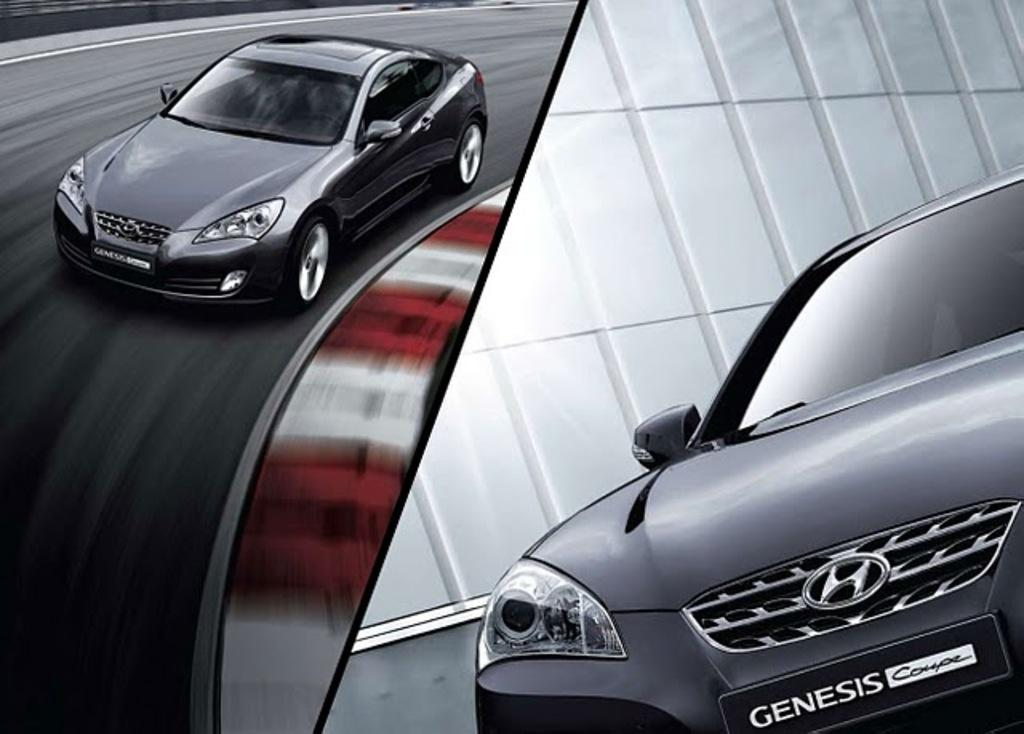What type of image is shown in the picture? The image is a photo collage. What can be seen in the collage? There is a car in the collage. What is the car doing in the collage? The car is moving on the road. What color is the car in the collage? The car is black in color. Can you see a badge on the donkey in the collage? There is no donkey present in the collage, and therefore no badge can be seen on it. 